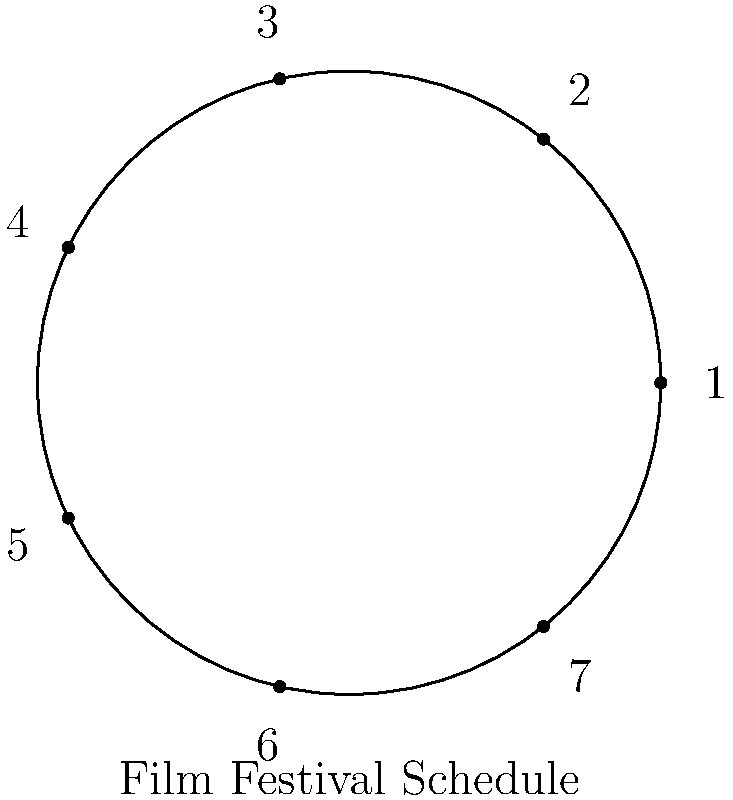A prestigious film festival schedules its screenings in a recurring weekly pattern. The diagram represents this schedule, where each number corresponds to a day of the week (1 = Monday, 2 = Tuesday, etc.). If a certain classic movie starring Humphrey Bogart is always screened on Wednesdays, how many weeks must pass before it's shown on a Wednesday again? Express your answer in terms of the order of the cyclic group represented by this schedule. To solve this problem, we need to understand the concept of cyclic groups and how they relate to the given film festival schedule:

1) The diagram represents a cyclic group of order 7, as there are 7 distinct elements (days of the week) that cycle in a fixed order.

2) In group theory, the order of an element is the smallest positive integer $n$ such that $a^n = e$, where $e$ is the identity element.

3) In this case, each "step" represents moving forward one day. We want to know how many steps it takes to get back to Wednesday.

4) Wednesday is represented by the number 3 in the diagram.

5) To get back to Wednesday, we need to complete a full cycle. In a cyclic group of order 7, this means we need to apply the operation (move forward) 7 times.

6) Therefore, it will take 7 weeks before the Humphrey Bogart classic is shown on a Wednesday again.

7) The order of the cyclic group represented by this schedule is 7.

Thus, the number of weeks is equal to the order of the cyclic group.
Answer: 7 